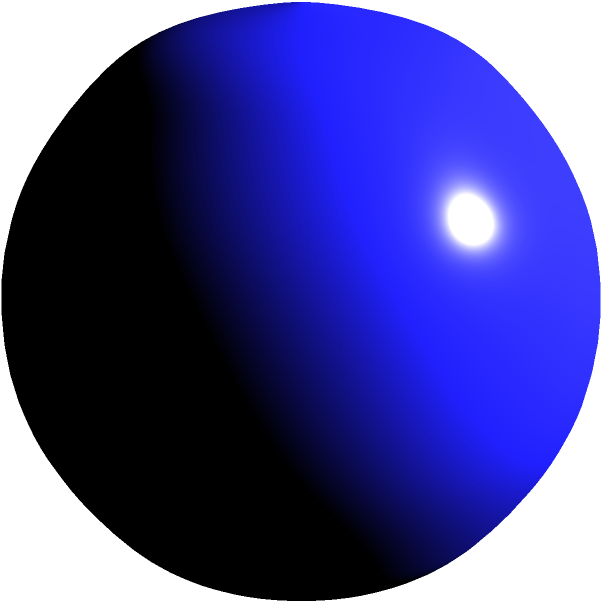In a drug discovery project, you are working with spherical nanoparticles for targeted drug delivery. Given a nanoparticle with a diameter of 10 nm, calculate its surface area in square nanometers (nm²). Round your answer to the nearest whole number. To calculate the surface area of a spherical nanoparticle, we can use the formula for the surface area of a sphere:

$$ A = 4\pi r^2 $$

Where:
$A$ is the surface area
$r$ is the radius of the sphere

Step 1: Determine the radius
The diameter is given as 10 nm, so the radius is half of that:
$$ r = \frac{10 \text{ nm}}{2} = 5 \text{ nm} $$

Step 2: Apply the surface area formula
$$ A = 4\pi r^2 $$
$$ A = 4\pi (5 \text{ nm})^2 $$
$$ A = 4\pi (25 \text{ nm}^2) $$
$$ A = 100\pi \text{ nm}^2 $$

Step 3: Calculate the result
$$ A \approx 314.159 \text{ nm}^2 $$

Step 4: Round to the nearest whole number
$$ A \approx 314 \text{ nm}^2 $$

This surface area value is crucial for understanding the nanoparticle's potential for drug loading and interaction with biological systems in the context of targeted drug delivery.
Answer: 314 nm² 